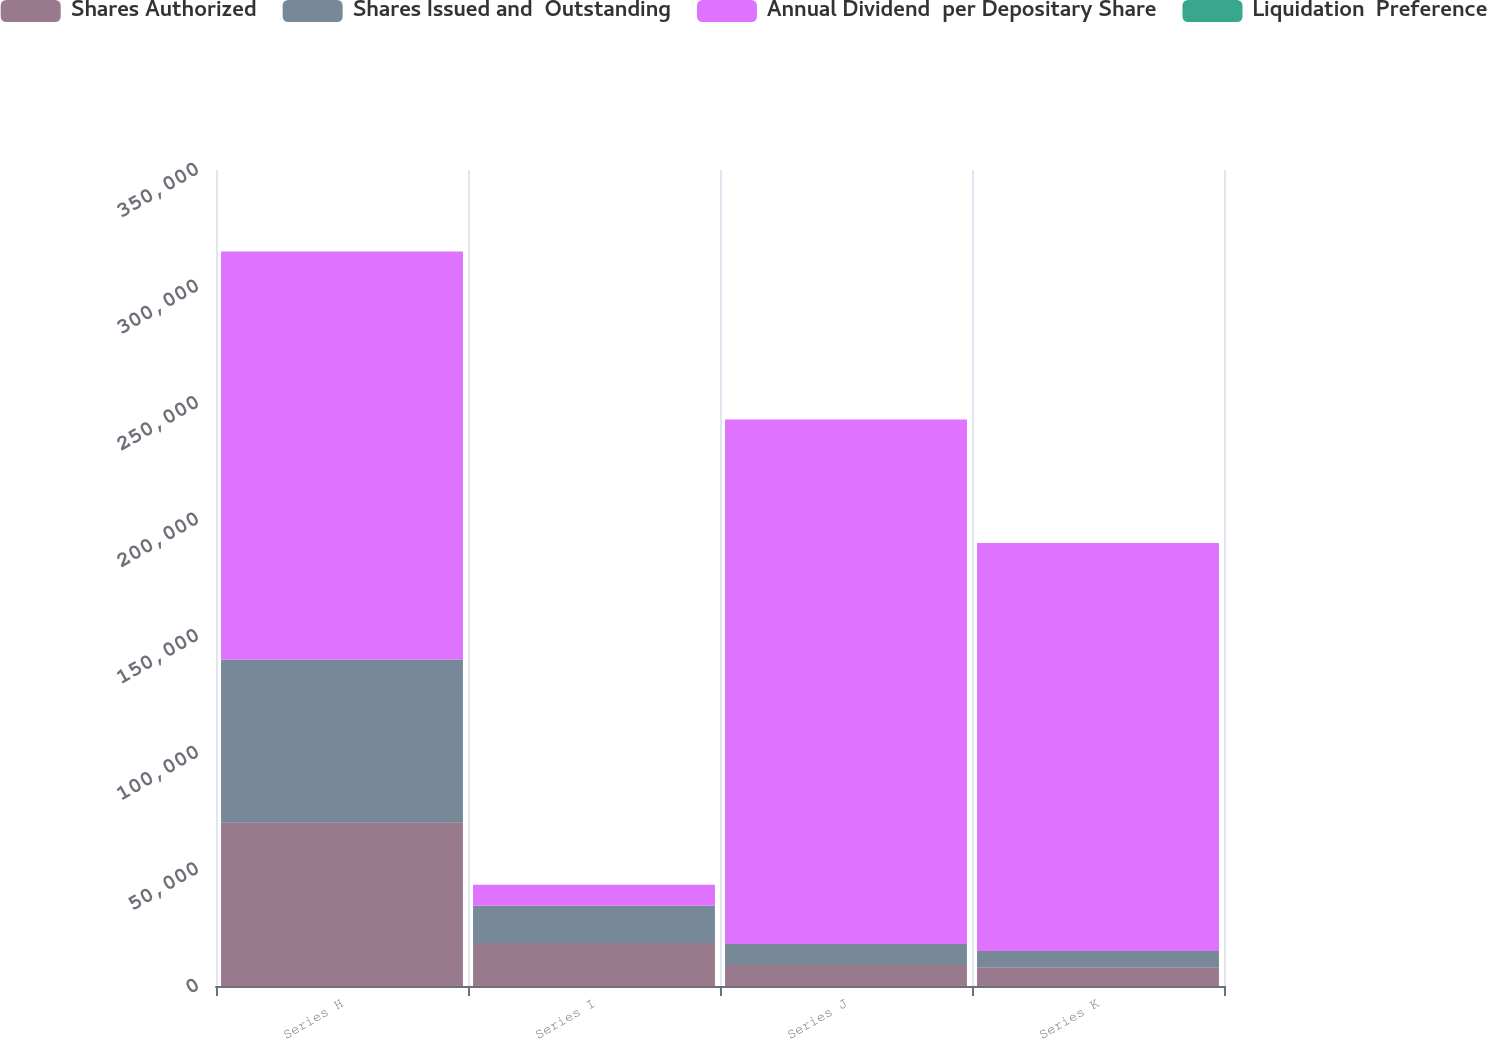<chart> <loc_0><loc_0><loc_500><loc_500><stacked_bar_chart><ecel><fcel>Series H<fcel>Series I<fcel>Series J<fcel>Series K<nl><fcel>Shares Authorized<fcel>70000<fcel>18400<fcel>9000<fcel>8050<nl><fcel>Shares Issued and  Outstanding<fcel>70000<fcel>16000<fcel>9000<fcel>7000<nl><fcel>Annual Dividend  per Depositary Share<fcel>175000<fcel>9000<fcel>225000<fcel>175000<nl><fcel>Liquidation  Preference<fcel>6.9<fcel>6<fcel>5.5<fcel>5.62<nl></chart> 